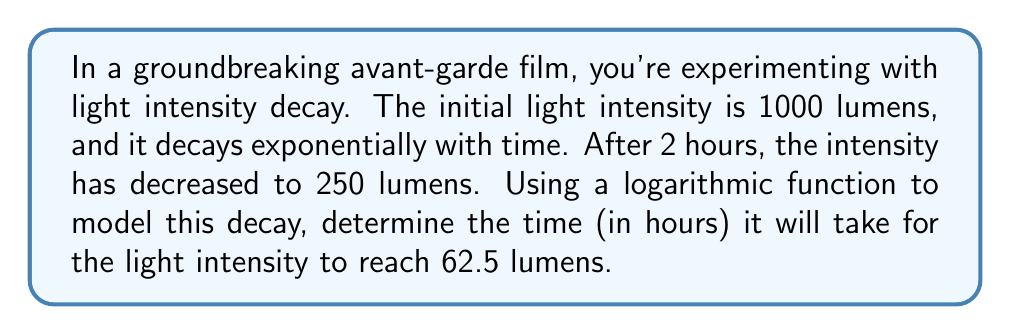Provide a solution to this math problem. Let's approach this step-by-step:

1) The general form of exponential decay is:
   $$I(t) = I_0 \cdot e^{-kt}$$
   where $I(t)$ is the intensity at time $t$, $I_0$ is the initial intensity, and $k$ is the decay constant.

2) We know:
   $I_0 = 1000$ lumens
   $I(2) = 250$ lumens

3) Let's find $k$ using the given information:
   $$250 = 1000 \cdot e^{-2k}$$

4) Divide both sides by 1000:
   $$0.25 = e^{-2k}$$

5) Take the natural log of both sides:
   $$\ln(0.25) = -2k$$

6) Solve for $k$:
   $$k = -\frac{\ln(0.25)}{2} = \frac{\ln(4)}{2} \approx 0.6931$$

7) Now, we want to find $t$ when $I(t) = 62.5$. Let's use the decay formula:
   $$62.5 = 1000 \cdot e^{-0.6931t}$$

8) Divide both sides by 1000:
   $$0.0625 = e^{-0.6931t}$$

9) Take the natural log of both sides:
   $$\ln(0.0625) = -0.6931t$$

10) Solve for $t$:
    $$t = -\frac{\ln(0.0625)}{0.6931} = \frac{\ln(16)}{0.6931} \approx 4$$

Therefore, it will take approximately 4 hours for the light intensity to reach 62.5 lumens.
Answer: 4 hours 